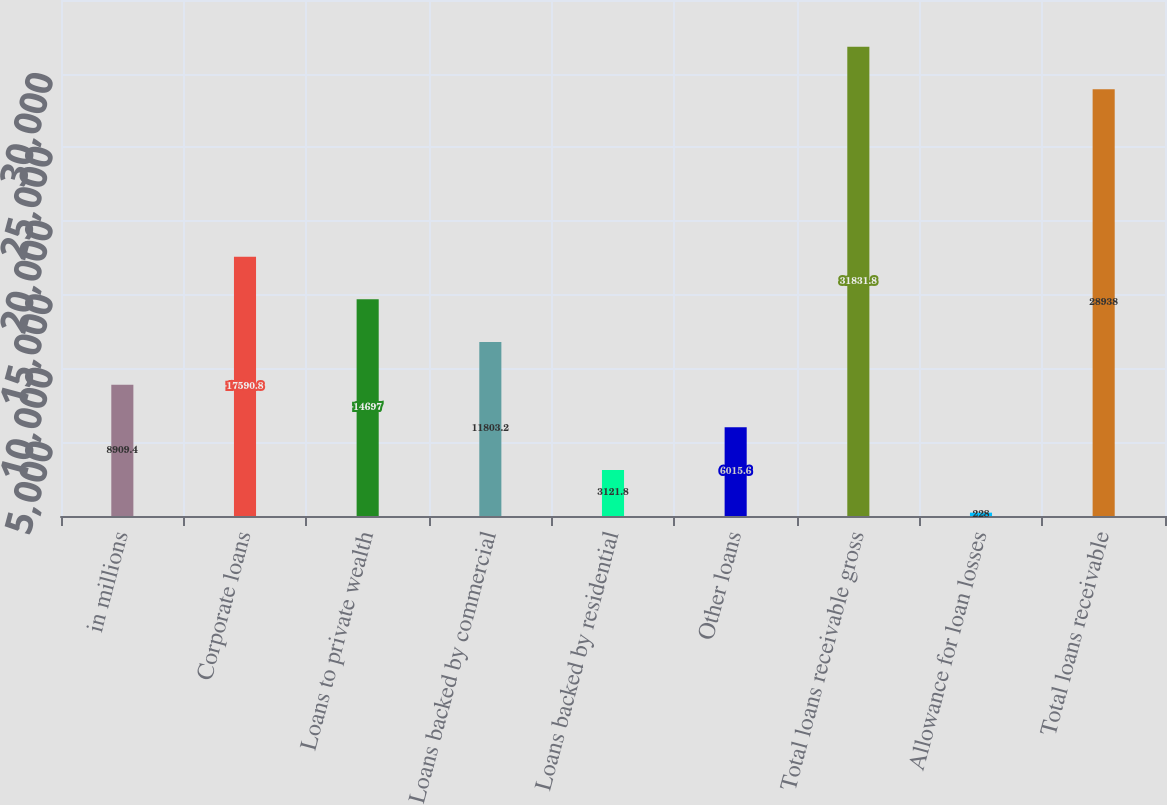Convert chart to OTSL. <chart><loc_0><loc_0><loc_500><loc_500><bar_chart><fcel>in millions<fcel>Corporate loans<fcel>Loans to private wealth<fcel>Loans backed by commercial<fcel>Loans backed by residential<fcel>Other loans<fcel>Total loans receivable gross<fcel>Allowance for loan losses<fcel>Total loans receivable<nl><fcel>8909.4<fcel>17590.8<fcel>14697<fcel>11803.2<fcel>3121.8<fcel>6015.6<fcel>31831.8<fcel>228<fcel>28938<nl></chart> 